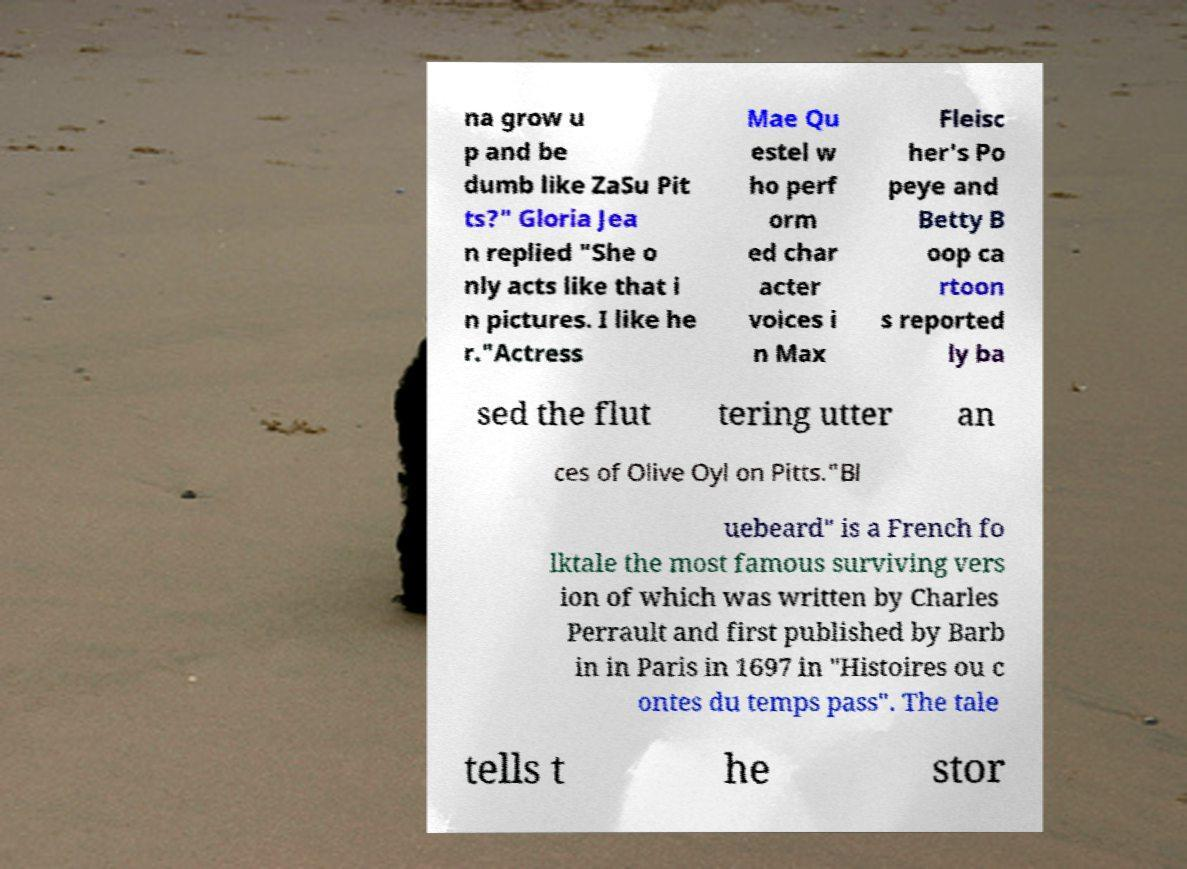What messages or text are displayed in this image? I need them in a readable, typed format. na grow u p and be dumb like ZaSu Pit ts?" Gloria Jea n replied "She o nly acts like that i n pictures. I like he r."Actress Mae Qu estel w ho perf orm ed char acter voices i n Max Fleisc her's Po peye and Betty B oop ca rtoon s reported ly ba sed the flut tering utter an ces of Olive Oyl on Pitts."Bl uebeard" is a French fo lktale the most famous surviving vers ion of which was written by Charles Perrault and first published by Barb in in Paris in 1697 in "Histoires ou c ontes du temps pass". The tale tells t he stor 